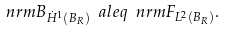Convert formula to latex. <formula><loc_0><loc_0><loc_500><loc_500>\ n r m { B } _ { \dot { H } ^ { 1 } ( B _ { R } ) } \ a l e q \ n r m { F } _ { L ^ { 2 } ( B _ { R } ) } .</formula> 